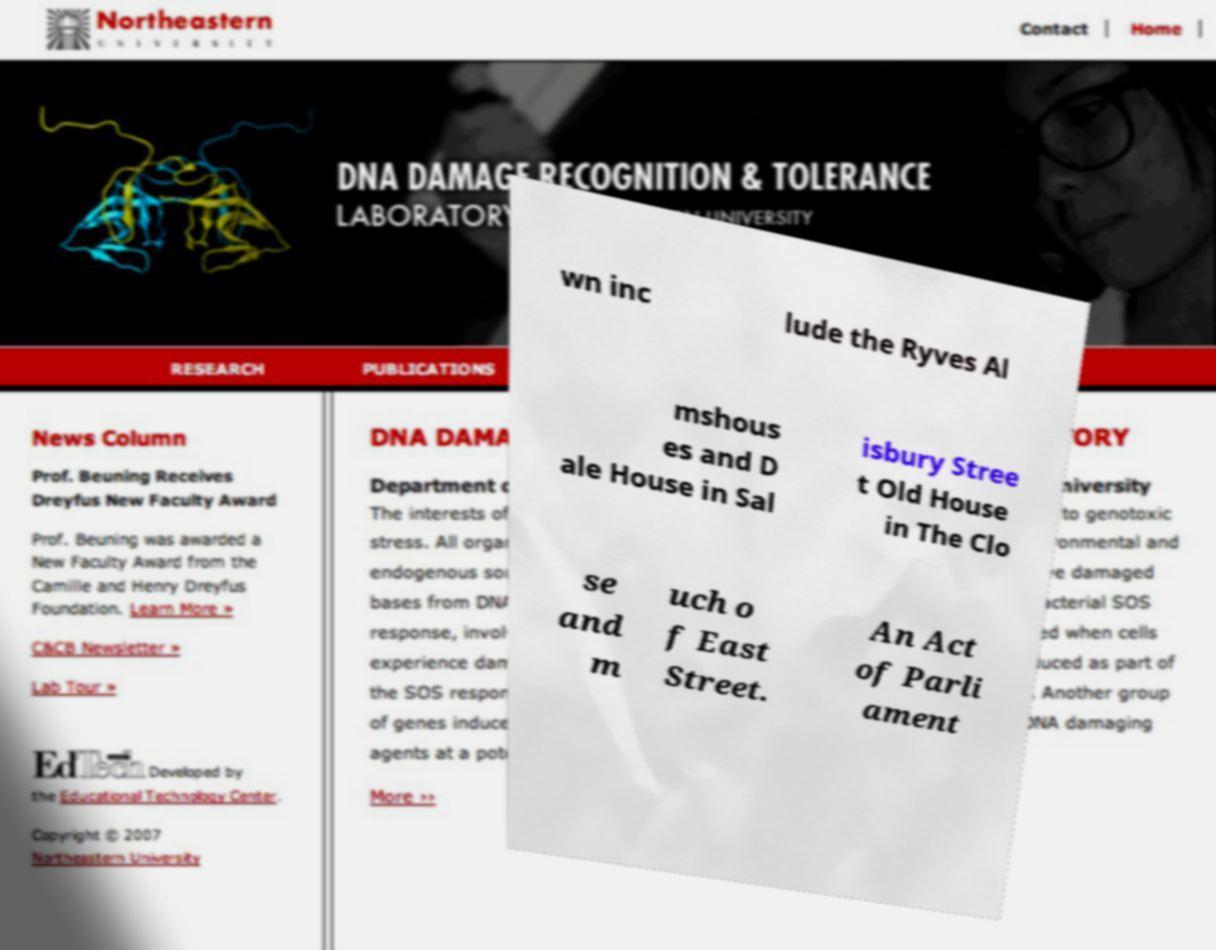I need the written content from this picture converted into text. Can you do that? wn inc lude the Ryves Al mshous es and D ale House in Sal isbury Stree t Old House in The Clo se and m uch o f East Street. An Act of Parli ament 